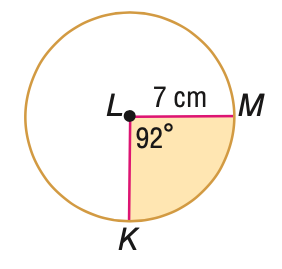Answer the mathemtical geometry problem and directly provide the correct option letter.
Question: Find the area of the shaded sector. Round to the nearest tenth.
Choices: A: 32.7 B: 39.3 C: 114.6 D: 153.9 B 